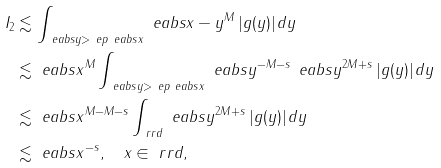<formula> <loc_0><loc_0><loc_500><loc_500>I _ { 2 } & \lesssim \int _ { \ e a b s { y } > \ e p \ e a b s { x } } \ e a b s { x - y } ^ { M } \, | g ( y ) | \, d y \\ & \lesssim \ e a b s { x } ^ { M } \int _ { \ e a b s { y } > \ e p \ e a b s { x } } \ e a b s { y } ^ { - M - s } \, \ e a b s { y } ^ { 2 M + s } \, | g ( y ) | \, d y \\ & \lesssim \ e a b s { x } ^ { M - M - s } \int _ { \ r r d } \ e a b s { y } ^ { 2 M + s } \, | g ( y ) | \, d y \\ & \lesssim \ e a b s { x } ^ { - s } , \quad x \in \ r r d ,</formula> 